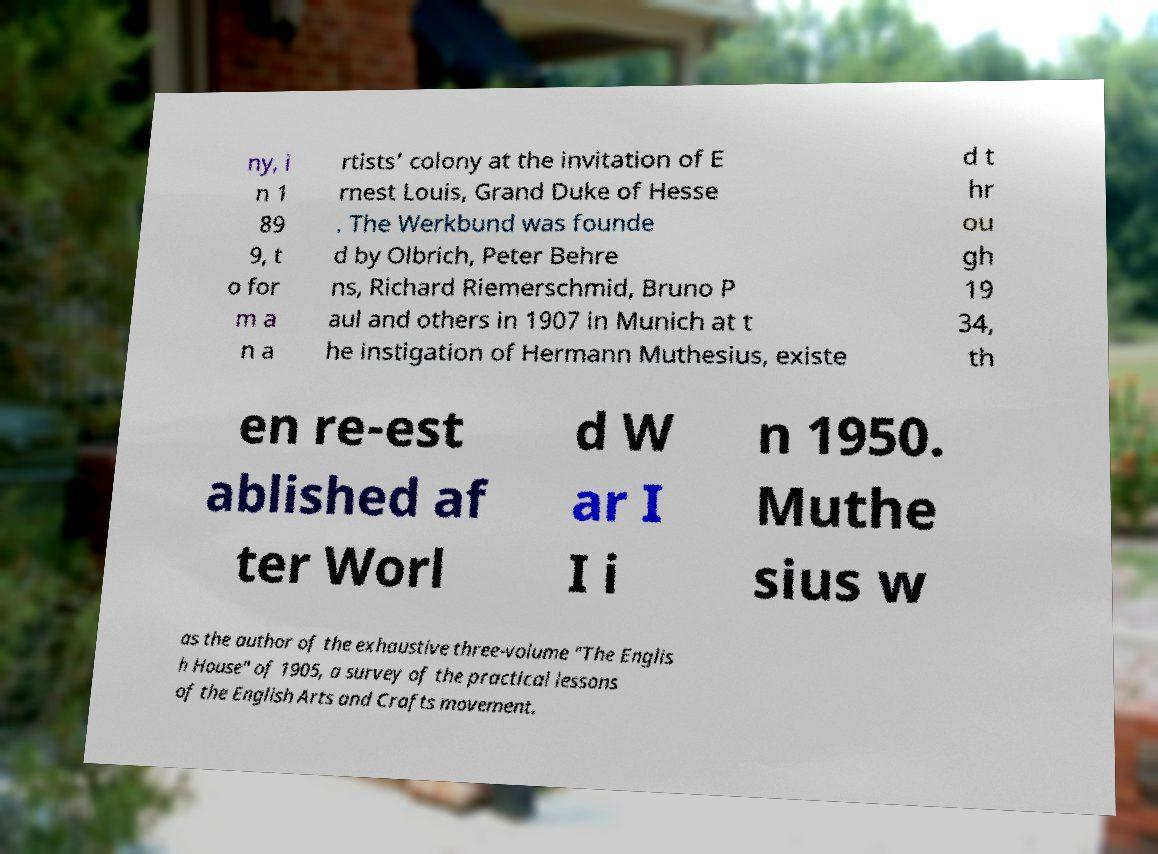For documentation purposes, I need the text within this image transcribed. Could you provide that? ny, i n 1 89 9, t o for m a n a rtists’ colony at the invitation of E rnest Louis, Grand Duke of Hesse . The Werkbund was founde d by Olbrich, Peter Behre ns, Richard Riemerschmid, Bruno P aul and others in 1907 in Munich at t he instigation of Hermann Muthesius, existe d t hr ou gh 19 34, th en re-est ablished af ter Worl d W ar I I i n 1950. Muthe sius w as the author of the exhaustive three-volume "The Englis h House" of 1905, a survey of the practical lessons of the English Arts and Crafts movement. 